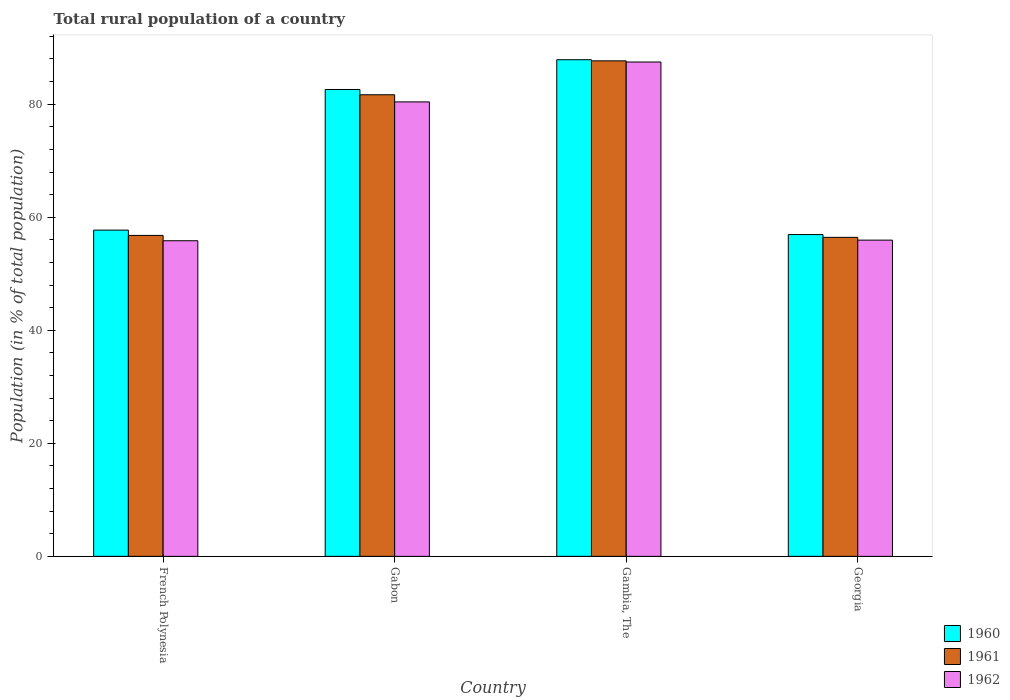Are the number of bars on each tick of the X-axis equal?
Offer a terse response. Yes. How many bars are there on the 1st tick from the left?
Provide a short and direct response. 3. What is the label of the 4th group of bars from the left?
Give a very brief answer. Georgia. What is the rural population in 1962 in French Polynesia?
Provide a succinct answer. 55.84. Across all countries, what is the maximum rural population in 1961?
Offer a terse response. 87.67. Across all countries, what is the minimum rural population in 1960?
Your response must be concise. 56.93. In which country was the rural population in 1962 maximum?
Provide a succinct answer. Gambia, The. In which country was the rural population in 1962 minimum?
Provide a succinct answer. French Polynesia. What is the total rural population in 1962 in the graph?
Ensure brevity in your answer.  279.66. What is the difference between the rural population in 1961 in French Polynesia and that in Gambia, The?
Offer a very short reply. -30.89. What is the difference between the rural population in 1961 in Gambia, The and the rural population in 1962 in Gabon?
Provide a short and direct response. 7.26. What is the average rural population in 1962 per country?
Make the answer very short. 69.92. What is the difference between the rural population of/in 1961 and rural population of/in 1960 in Georgia?
Give a very brief answer. -0.49. What is the ratio of the rural population in 1960 in Gabon to that in Georgia?
Your answer should be very brief. 1.45. Is the rural population in 1962 in French Polynesia less than that in Georgia?
Make the answer very short. Yes. Is the difference between the rural population in 1961 in French Polynesia and Gabon greater than the difference between the rural population in 1960 in French Polynesia and Gabon?
Make the answer very short. No. What is the difference between the highest and the second highest rural population in 1962?
Give a very brief answer. 24.46. What is the difference between the highest and the lowest rural population in 1960?
Your answer should be very brief. 30.94. In how many countries, is the rural population in 1962 greater than the average rural population in 1962 taken over all countries?
Provide a succinct answer. 2. What does the 2nd bar from the left in Georgia represents?
Offer a very short reply. 1961. What does the 1st bar from the right in French Polynesia represents?
Your response must be concise. 1962. Is it the case that in every country, the sum of the rural population in 1960 and rural population in 1962 is greater than the rural population in 1961?
Make the answer very short. Yes. How many bars are there?
Keep it short and to the point. 12. How many countries are there in the graph?
Your answer should be very brief. 4. Does the graph contain grids?
Give a very brief answer. No. Where does the legend appear in the graph?
Keep it short and to the point. Bottom right. How many legend labels are there?
Your response must be concise. 3. How are the legend labels stacked?
Your answer should be very brief. Vertical. What is the title of the graph?
Your response must be concise. Total rural population of a country. What is the label or title of the X-axis?
Give a very brief answer. Country. What is the label or title of the Y-axis?
Provide a short and direct response. Population (in % of total population). What is the Population (in % of total population) of 1960 in French Polynesia?
Your answer should be very brief. 57.72. What is the Population (in % of total population) in 1961 in French Polynesia?
Make the answer very short. 56.78. What is the Population (in % of total population) in 1962 in French Polynesia?
Your answer should be compact. 55.84. What is the Population (in % of total population) in 1960 in Gabon?
Make the answer very short. 82.6. What is the Population (in % of total population) in 1961 in Gabon?
Make the answer very short. 81.67. What is the Population (in % of total population) of 1962 in Gabon?
Provide a succinct answer. 80.41. What is the Population (in % of total population) of 1960 in Gambia, The?
Provide a succinct answer. 87.87. What is the Population (in % of total population) in 1961 in Gambia, The?
Your answer should be compact. 87.67. What is the Population (in % of total population) of 1962 in Gambia, The?
Provide a succinct answer. 87.47. What is the Population (in % of total population) in 1960 in Georgia?
Provide a succinct answer. 56.93. What is the Population (in % of total population) of 1961 in Georgia?
Ensure brevity in your answer.  56.44. What is the Population (in % of total population) of 1962 in Georgia?
Provide a succinct answer. 55.95. Across all countries, what is the maximum Population (in % of total population) of 1960?
Provide a short and direct response. 87.87. Across all countries, what is the maximum Population (in % of total population) in 1961?
Offer a terse response. 87.67. Across all countries, what is the maximum Population (in % of total population) in 1962?
Keep it short and to the point. 87.47. Across all countries, what is the minimum Population (in % of total population) in 1960?
Offer a terse response. 56.93. Across all countries, what is the minimum Population (in % of total population) of 1961?
Give a very brief answer. 56.44. Across all countries, what is the minimum Population (in % of total population) in 1962?
Give a very brief answer. 55.84. What is the total Population (in % of total population) in 1960 in the graph?
Ensure brevity in your answer.  285.12. What is the total Population (in % of total population) of 1961 in the graph?
Your answer should be very brief. 282.56. What is the total Population (in % of total population) of 1962 in the graph?
Provide a succinct answer. 279.66. What is the difference between the Population (in % of total population) of 1960 in French Polynesia and that in Gabon?
Make the answer very short. -24.88. What is the difference between the Population (in % of total population) of 1961 in French Polynesia and that in Gabon?
Your answer should be very brief. -24.89. What is the difference between the Population (in % of total population) in 1962 in French Polynesia and that in Gabon?
Give a very brief answer. -24.57. What is the difference between the Population (in % of total population) in 1960 in French Polynesia and that in Gambia, The?
Your answer should be very brief. -30.15. What is the difference between the Population (in % of total population) of 1961 in French Polynesia and that in Gambia, The?
Provide a succinct answer. -30.89. What is the difference between the Population (in % of total population) in 1962 in French Polynesia and that in Gambia, The?
Your answer should be compact. -31.62. What is the difference between the Population (in % of total population) in 1960 in French Polynesia and that in Georgia?
Make the answer very short. 0.79. What is the difference between the Population (in % of total population) of 1961 in French Polynesia and that in Georgia?
Provide a succinct answer. 0.34. What is the difference between the Population (in % of total population) in 1962 in French Polynesia and that in Georgia?
Offer a terse response. -0.11. What is the difference between the Population (in % of total population) of 1960 in Gabon and that in Gambia, The?
Give a very brief answer. -5.27. What is the difference between the Population (in % of total population) in 1961 in Gabon and that in Gambia, The?
Provide a short and direct response. -6. What is the difference between the Population (in % of total population) of 1962 in Gabon and that in Gambia, The?
Your answer should be very brief. -7.06. What is the difference between the Population (in % of total population) in 1960 in Gabon and that in Georgia?
Your response must be concise. 25.67. What is the difference between the Population (in % of total population) of 1961 in Gabon and that in Georgia?
Provide a short and direct response. 25.23. What is the difference between the Population (in % of total population) in 1962 in Gabon and that in Georgia?
Offer a very short reply. 24.46. What is the difference between the Population (in % of total population) of 1960 in Gambia, The and that in Georgia?
Provide a succinct answer. 30.94. What is the difference between the Population (in % of total population) in 1961 in Gambia, The and that in Georgia?
Offer a very short reply. 31.23. What is the difference between the Population (in % of total population) of 1962 in Gambia, The and that in Georgia?
Offer a very short reply. 31.52. What is the difference between the Population (in % of total population) of 1960 in French Polynesia and the Population (in % of total population) of 1961 in Gabon?
Keep it short and to the point. -23.95. What is the difference between the Population (in % of total population) of 1960 in French Polynesia and the Population (in % of total population) of 1962 in Gabon?
Provide a short and direct response. -22.69. What is the difference between the Population (in % of total population) in 1961 in French Polynesia and the Population (in % of total population) in 1962 in Gabon?
Your answer should be compact. -23.62. What is the difference between the Population (in % of total population) in 1960 in French Polynesia and the Population (in % of total population) in 1961 in Gambia, The?
Keep it short and to the point. -29.95. What is the difference between the Population (in % of total population) of 1960 in French Polynesia and the Population (in % of total population) of 1962 in Gambia, The?
Your answer should be compact. -29.75. What is the difference between the Population (in % of total population) of 1961 in French Polynesia and the Population (in % of total population) of 1962 in Gambia, The?
Give a very brief answer. -30.68. What is the difference between the Population (in % of total population) in 1960 in French Polynesia and the Population (in % of total population) in 1961 in Georgia?
Your answer should be compact. 1.28. What is the difference between the Population (in % of total population) of 1960 in French Polynesia and the Population (in % of total population) of 1962 in Georgia?
Your answer should be compact. 1.77. What is the difference between the Population (in % of total population) of 1961 in French Polynesia and the Population (in % of total population) of 1962 in Georgia?
Provide a short and direct response. 0.83. What is the difference between the Population (in % of total population) in 1960 in Gabon and the Population (in % of total population) in 1961 in Gambia, The?
Provide a succinct answer. -5.07. What is the difference between the Population (in % of total population) of 1960 in Gabon and the Population (in % of total population) of 1962 in Gambia, The?
Give a very brief answer. -4.86. What is the difference between the Population (in % of total population) in 1961 in Gabon and the Population (in % of total population) in 1962 in Gambia, The?
Give a very brief answer. -5.79. What is the difference between the Population (in % of total population) of 1960 in Gabon and the Population (in % of total population) of 1961 in Georgia?
Offer a terse response. 26.16. What is the difference between the Population (in % of total population) in 1960 in Gabon and the Population (in % of total population) in 1962 in Georgia?
Offer a very short reply. 26.65. What is the difference between the Population (in % of total population) in 1961 in Gabon and the Population (in % of total population) in 1962 in Georgia?
Your answer should be very brief. 25.72. What is the difference between the Population (in % of total population) of 1960 in Gambia, The and the Population (in % of total population) of 1961 in Georgia?
Provide a short and direct response. 31.43. What is the difference between the Population (in % of total population) of 1960 in Gambia, The and the Population (in % of total population) of 1962 in Georgia?
Keep it short and to the point. 31.92. What is the difference between the Population (in % of total population) of 1961 in Gambia, The and the Population (in % of total population) of 1962 in Georgia?
Offer a terse response. 31.72. What is the average Population (in % of total population) in 1960 per country?
Offer a terse response. 71.28. What is the average Population (in % of total population) in 1961 per country?
Keep it short and to the point. 70.64. What is the average Population (in % of total population) in 1962 per country?
Ensure brevity in your answer.  69.92. What is the difference between the Population (in % of total population) in 1960 and Population (in % of total population) in 1961 in French Polynesia?
Provide a succinct answer. 0.94. What is the difference between the Population (in % of total population) in 1960 and Population (in % of total population) in 1962 in French Polynesia?
Make the answer very short. 1.88. What is the difference between the Population (in % of total population) in 1961 and Population (in % of total population) in 1962 in French Polynesia?
Keep it short and to the point. 0.94. What is the difference between the Population (in % of total population) in 1960 and Population (in % of total population) in 1961 in Gabon?
Provide a succinct answer. 0.93. What is the difference between the Population (in % of total population) of 1960 and Population (in % of total population) of 1962 in Gabon?
Give a very brief answer. 2.2. What is the difference between the Population (in % of total population) in 1961 and Population (in % of total population) in 1962 in Gabon?
Your answer should be very brief. 1.26. What is the difference between the Population (in % of total population) of 1960 and Population (in % of total population) of 1961 in Gambia, The?
Your response must be concise. 0.2. What is the difference between the Population (in % of total population) in 1960 and Population (in % of total population) in 1962 in Gambia, The?
Your answer should be compact. 0.41. What is the difference between the Population (in % of total population) of 1961 and Population (in % of total population) of 1962 in Gambia, The?
Provide a succinct answer. 0.2. What is the difference between the Population (in % of total population) of 1960 and Population (in % of total population) of 1961 in Georgia?
Offer a terse response. 0.49. What is the difference between the Population (in % of total population) of 1960 and Population (in % of total population) of 1962 in Georgia?
Your answer should be compact. 0.98. What is the difference between the Population (in % of total population) in 1961 and Population (in % of total population) in 1962 in Georgia?
Keep it short and to the point. 0.49. What is the ratio of the Population (in % of total population) in 1960 in French Polynesia to that in Gabon?
Offer a terse response. 0.7. What is the ratio of the Population (in % of total population) of 1961 in French Polynesia to that in Gabon?
Offer a very short reply. 0.7. What is the ratio of the Population (in % of total population) in 1962 in French Polynesia to that in Gabon?
Offer a very short reply. 0.69. What is the ratio of the Population (in % of total population) of 1960 in French Polynesia to that in Gambia, The?
Make the answer very short. 0.66. What is the ratio of the Population (in % of total population) in 1961 in French Polynesia to that in Gambia, The?
Give a very brief answer. 0.65. What is the ratio of the Population (in % of total population) in 1962 in French Polynesia to that in Gambia, The?
Provide a succinct answer. 0.64. What is the ratio of the Population (in % of total population) of 1960 in French Polynesia to that in Georgia?
Ensure brevity in your answer.  1.01. What is the ratio of the Population (in % of total population) in 1961 in French Polynesia to that in Georgia?
Provide a short and direct response. 1.01. What is the ratio of the Population (in % of total population) in 1962 in French Polynesia to that in Georgia?
Keep it short and to the point. 1. What is the ratio of the Population (in % of total population) in 1960 in Gabon to that in Gambia, The?
Your answer should be compact. 0.94. What is the ratio of the Population (in % of total population) of 1961 in Gabon to that in Gambia, The?
Offer a very short reply. 0.93. What is the ratio of the Population (in % of total population) of 1962 in Gabon to that in Gambia, The?
Your answer should be compact. 0.92. What is the ratio of the Population (in % of total population) in 1960 in Gabon to that in Georgia?
Provide a succinct answer. 1.45. What is the ratio of the Population (in % of total population) in 1961 in Gabon to that in Georgia?
Give a very brief answer. 1.45. What is the ratio of the Population (in % of total population) of 1962 in Gabon to that in Georgia?
Offer a very short reply. 1.44. What is the ratio of the Population (in % of total population) in 1960 in Gambia, The to that in Georgia?
Ensure brevity in your answer.  1.54. What is the ratio of the Population (in % of total population) of 1961 in Gambia, The to that in Georgia?
Your response must be concise. 1.55. What is the ratio of the Population (in % of total population) in 1962 in Gambia, The to that in Georgia?
Make the answer very short. 1.56. What is the difference between the highest and the second highest Population (in % of total population) in 1960?
Provide a short and direct response. 5.27. What is the difference between the highest and the second highest Population (in % of total population) in 1961?
Ensure brevity in your answer.  6. What is the difference between the highest and the second highest Population (in % of total population) in 1962?
Offer a terse response. 7.06. What is the difference between the highest and the lowest Population (in % of total population) in 1960?
Ensure brevity in your answer.  30.94. What is the difference between the highest and the lowest Population (in % of total population) of 1961?
Give a very brief answer. 31.23. What is the difference between the highest and the lowest Population (in % of total population) of 1962?
Ensure brevity in your answer.  31.62. 